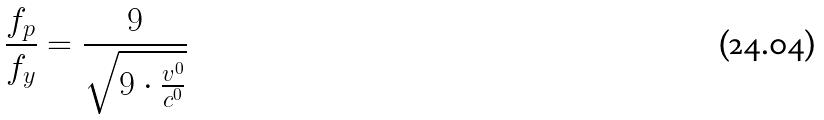<formula> <loc_0><loc_0><loc_500><loc_500>\frac { f _ { p } } { f _ { y } } = \frac { 9 } { \sqrt { 9 \cdot \frac { v ^ { 0 } } { c ^ { 0 } } } }</formula> 